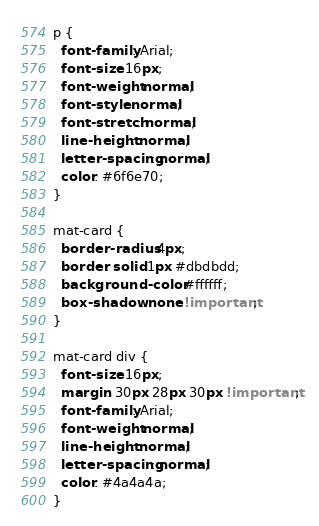Convert code to text. <code><loc_0><loc_0><loc_500><loc_500><_CSS_>p {
  font-family: Arial;
  font-size: 16px;
  font-weight: normal;
  font-style: normal;
  font-stretch: normal;
  line-height: normal;
  letter-spacing: normal;
  color: #6f6e70;
}

mat-card {
  border-radius: 4px;
  border: solid 1px #dbdbdd;
  background-color: #ffffff;
  box-shadow: none !important;
}

mat-card div {
  font-size: 16px;
  margin: 30px 28px 30px !important;
  font-family: Arial;
  font-weight: normal;
  line-height: normal;
  letter-spacing: normal;
  color: #4a4a4a;
}
</code> 